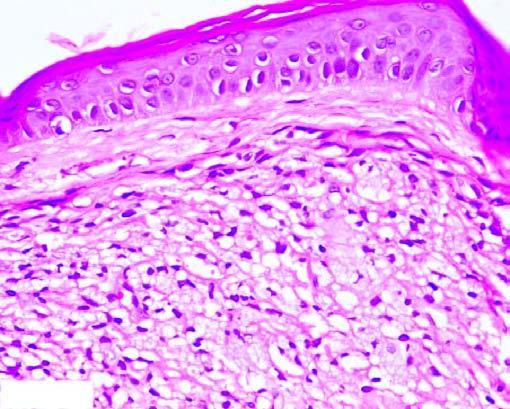what is there of proliferating foam macrophages in the dermis with a clear subepidermal zone?
Answer the question using a single word or phrase. Collection of proliferating foam macrophages 